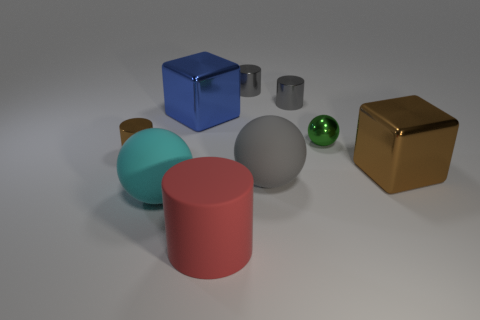Subtract all rubber spheres. How many spheres are left? 1 Subtract all red spheres. How many gray cylinders are left? 2 Subtract 1 cylinders. How many cylinders are left? 3 Subtract all brown cylinders. How many cylinders are left? 3 Subtract all spheres. How many objects are left? 6 Subtract all red cylinders. Subtract all red blocks. How many cylinders are left? 3 Add 4 cyan matte objects. How many cyan matte objects are left? 5 Add 6 cyan spheres. How many cyan spheres exist? 7 Subtract 0 yellow balls. How many objects are left? 9 Subtract all large blue things. Subtract all big blue shiny spheres. How many objects are left? 8 